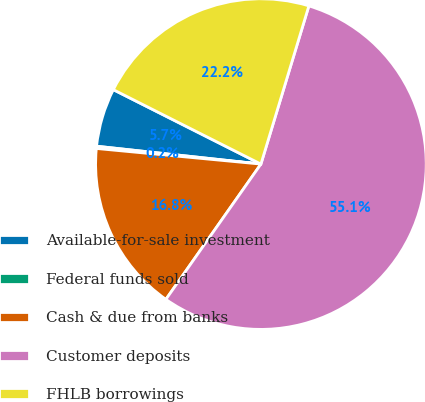Convert chart to OTSL. <chart><loc_0><loc_0><loc_500><loc_500><pie_chart><fcel>Available-for-sale investment<fcel>Federal funds sold<fcel>Cash & due from banks<fcel>Customer deposits<fcel>FHLB borrowings<nl><fcel>5.71%<fcel>0.22%<fcel>16.76%<fcel>55.06%<fcel>22.25%<nl></chart> 